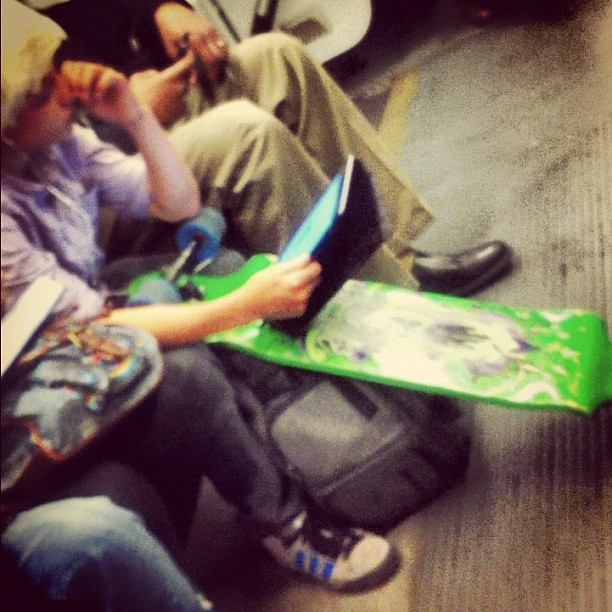Describe the objects in this image and their specific colors. I can see people in black, gray, darkgray, and maroon tones, people in black, tan, and gray tones, skateboard in black, beige, lightgreen, and darkgray tones, people in black, gray, darkgray, and beige tones, and backpack in black, gray, and darkgray tones in this image. 